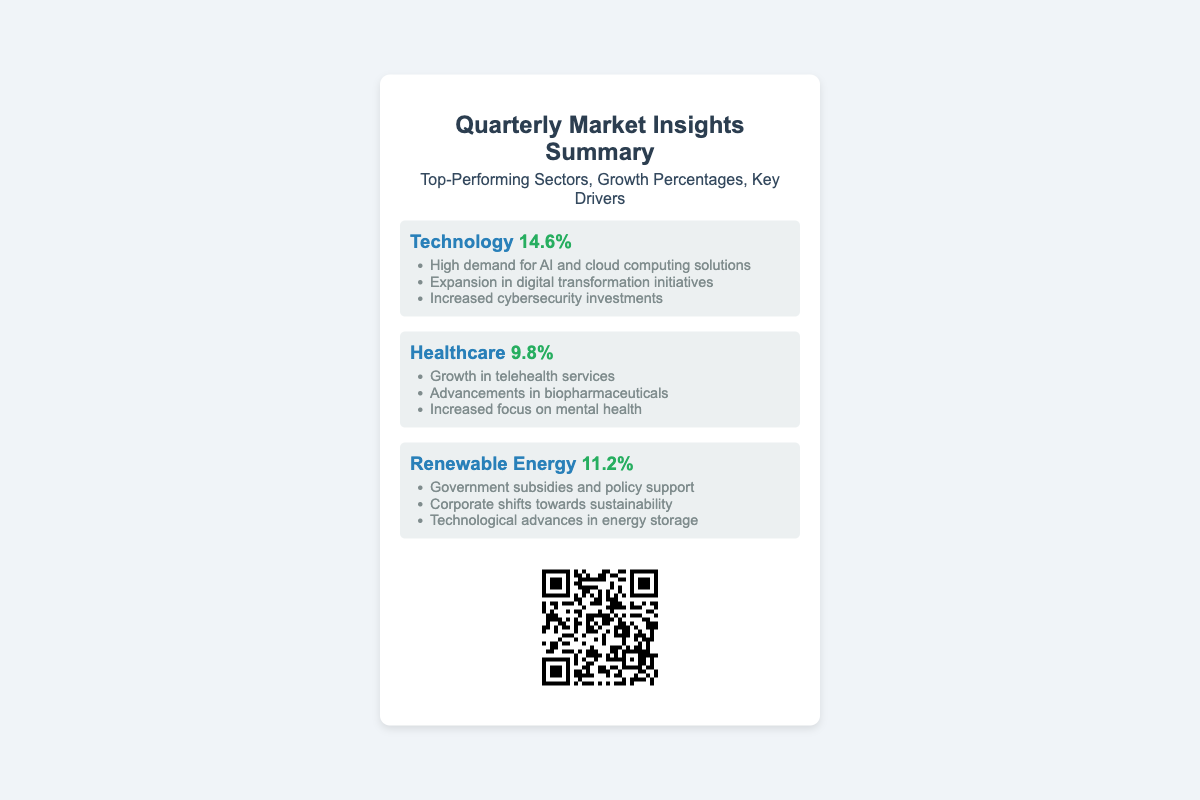What is the growth percentage for the Technology sector? The Technology sector shows a growth percentage indicated in the document.
Answer: 14.6% What key driver is contributing to the growth in Renewable Energy? The Renewable Energy sector lists multiple key drivers, one of which is cited in the document.
Answer: Government subsidies and policy support Which sector has the lowest growth percentage? Among the sectors listed, one has a lower growth percentage than the others.
Answer: Healthcare What is the overall theme of the document? The title of the document indicates the overall theme focusing on market insights.
Answer: Quarterly Market Insights Summary What type of services is experiencing growth in the Healthcare sector? The document mentions specific services under the Healthcare sector contributing to its growth.
Answer: Telehealth services How many top-performing sectors are highlighted in the summary? The document lists a specific number of sectors that perform top in the market.
Answer: Three What technological advancements are mentioned as a key driver for the Technology sector? The Technology sector includes various advancements relevant to its growth.
Answer: Increased cybersecurity investments What is linked by the QR code in the document? The QR code provides access to additional specific information detailed in the summary.
Answer: A detailed report 